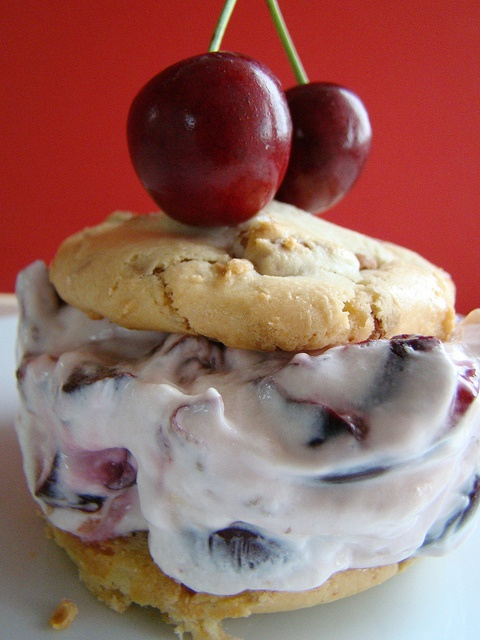Describe the objects in this image and their specific colors. I can see sandwich in maroon, darkgray, lightgray, and gray tones, apple in maroon and brown tones, and apple in maroon, black, brown, and lavender tones in this image. 